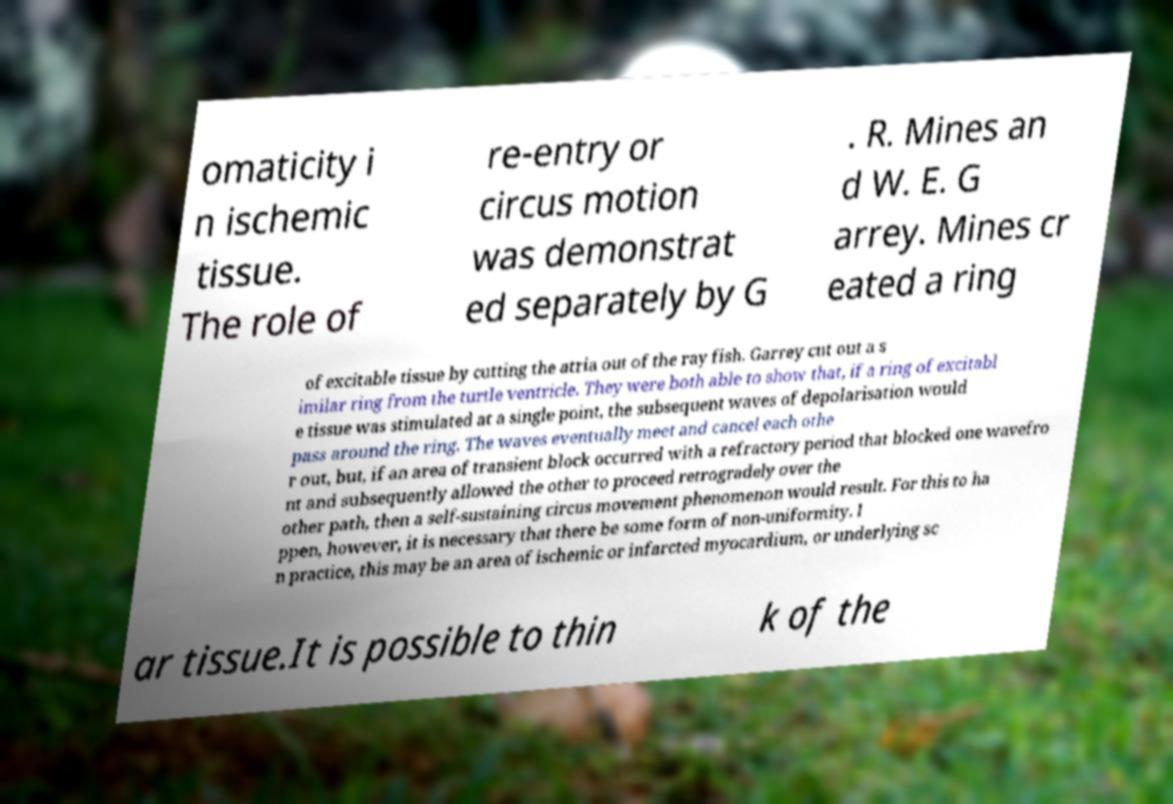Please read and relay the text visible in this image. What does it say? omaticity i n ischemic tissue. The role of re-entry or circus motion was demonstrat ed separately by G . R. Mines an d W. E. G arrey. Mines cr eated a ring of excitable tissue by cutting the atria out of the ray fish. Garrey cut out a s imilar ring from the turtle ventricle. They were both able to show that, if a ring of excitabl e tissue was stimulated at a single point, the subsequent waves of depolarisation would pass around the ring. The waves eventually meet and cancel each othe r out, but, if an area of transient block occurred with a refractory period that blocked one wavefro nt and subsequently allowed the other to proceed retrogradely over the other path, then a self-sustaining circus movement phenomenon would result. For this to ha ppen, however, it is necessary that there be some form of non-uniformity. I n practice, this may be an area of ischemic or infarcted myocardium, or underlying sc ar tissue.It is possible to thin k of the 